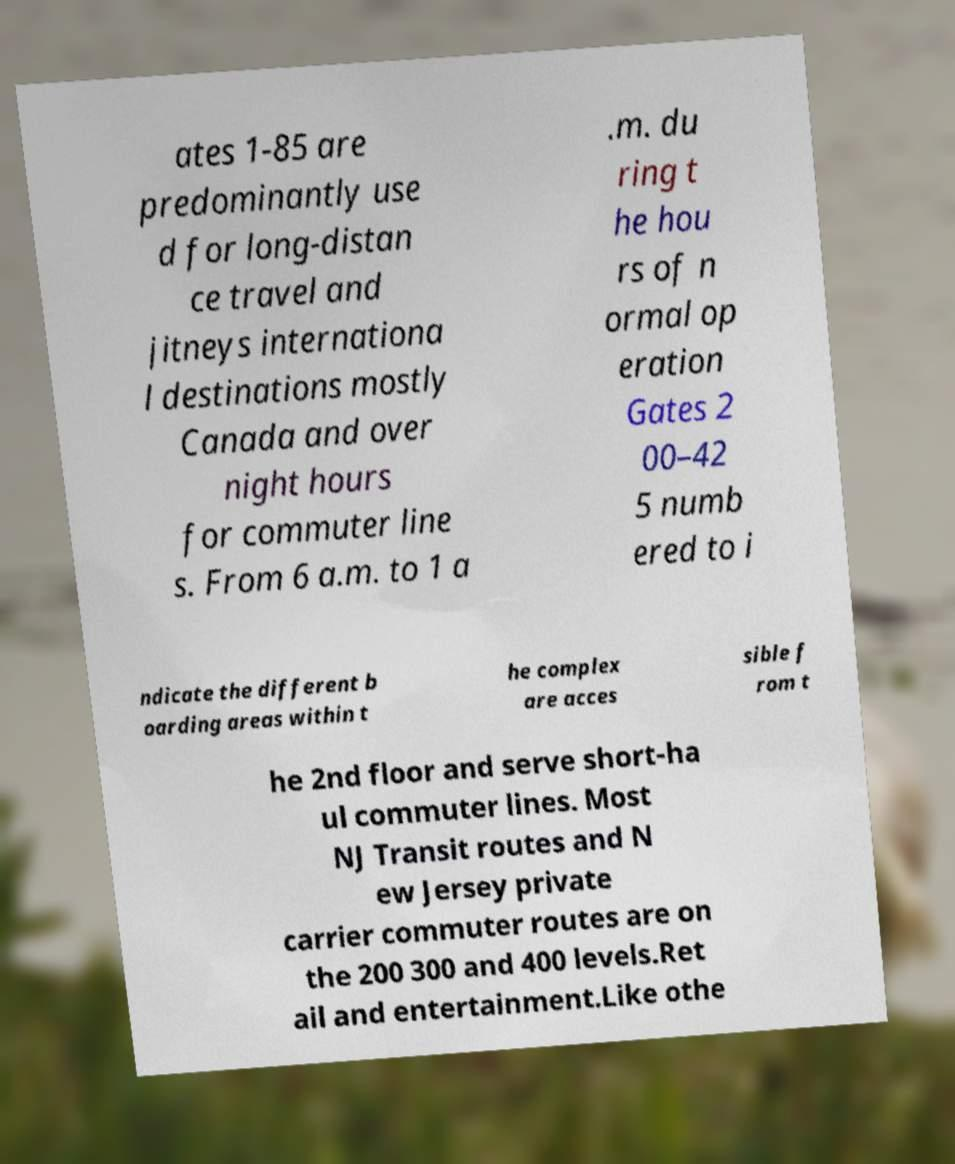What messages or text are displayed in this image? I need them in a readable, typed format. ates 1-85 are predominantly use d for long-distan ce travel and jitneys internationa l destinations mostly Canada and over night hours for commuter line s. From 6 a.m. to 1 a .m. du ring t he hou rs of n ormal op eration Gates 2 00–42 5 numb ered to i ndicate the different b oarding areas within t he complex are acces sible f rom t he 2nd floor and serve short-ha ul commuter lines. Most NJ Transit routes and N ew Jersey private carrier commuter routes are on the 200 300 and 400 levels.Ret ail and entertainment.Like othe 